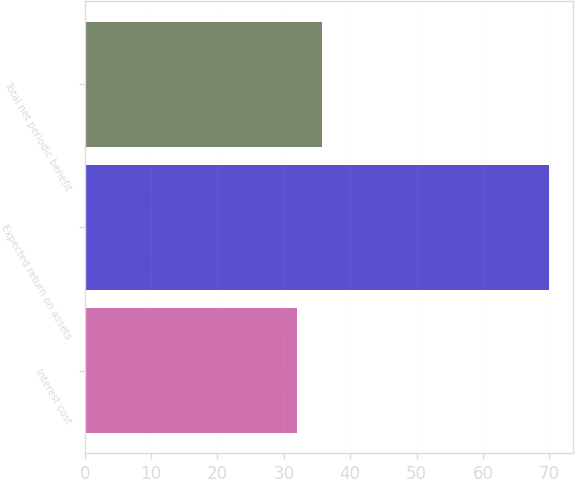Convert chart. <chart><loc_0><loc_0><loc_500><loc_500><bar_chart><fcel>Interest cost<fcel>Expected return on assets<fcel>Total net periodic benefit<nl><fcel>32<fcel>70<fcel>35.8<nl></chart> 